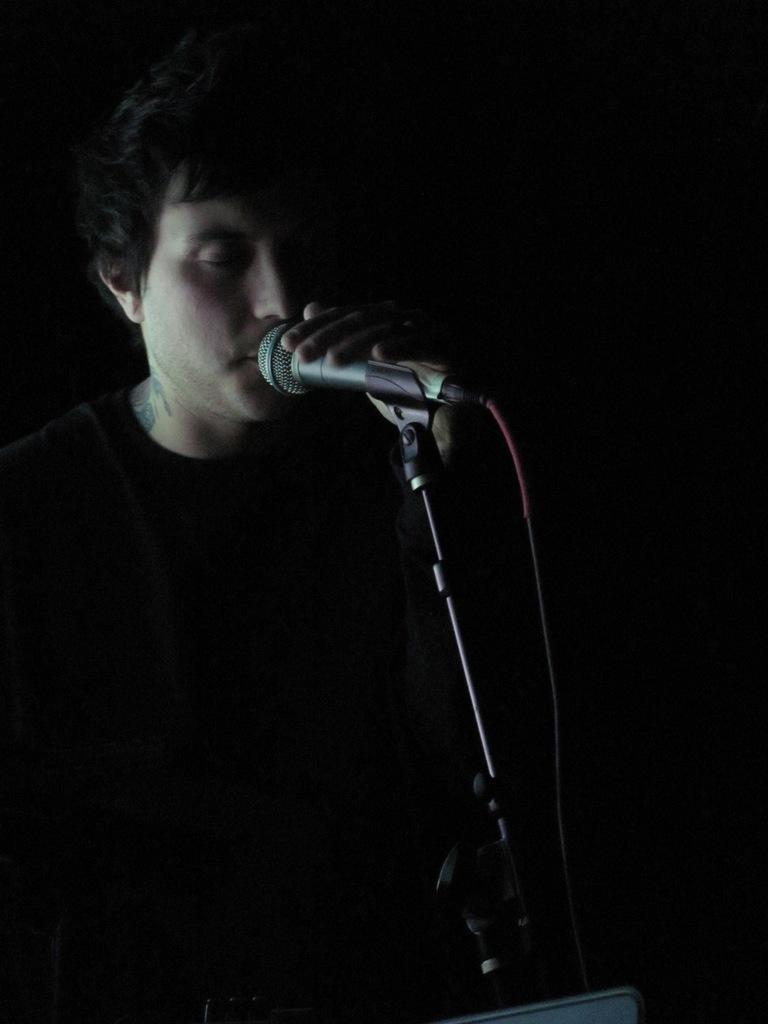Please provide a concise description of this image. In the center of the image we can see one person is holding a microphone. And we can see the dark background. 